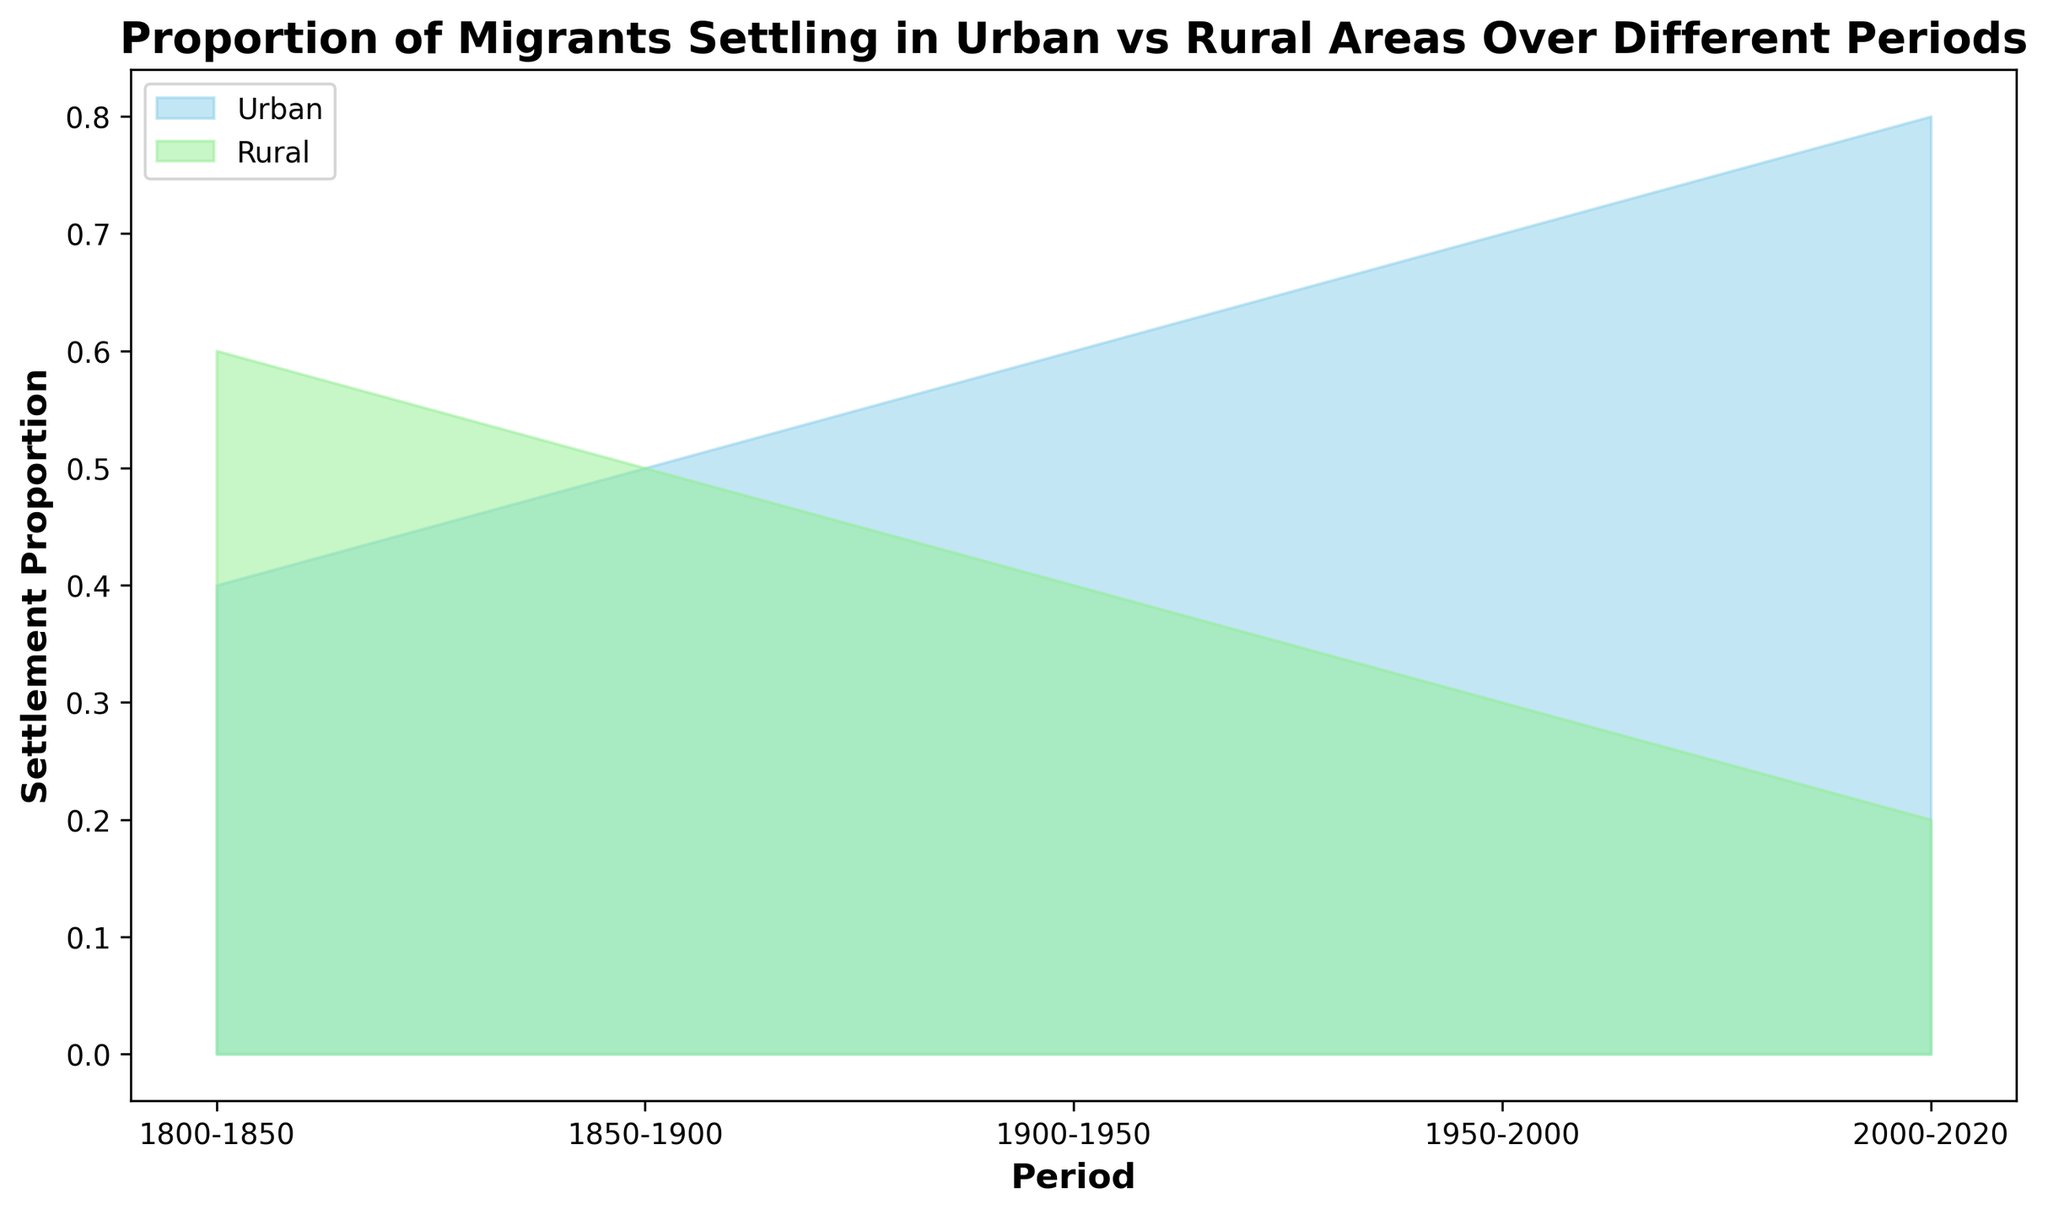What period had the lowest proportion of migrants settling in rural areas? Look at the area chart and identify the period where the green area (representing rural areas) is smallest relative to the total. In the period 2000-2020, the rural proportion is 0.20, the smallest proportion among all periods.
Answer: 2000-2020 How does the proportion of migrants settling in urban areas in 1900-1950 compare to 1800-1850? Check the height of the blue area representing urban areas in the periods 1900-1950 and 1800-1850. The urban proportion for 1900-1950 is 0.60, whereas for 1800-1850, it is 0.40, indicating an increase.
Answer: The proportion increased By how much did the urban settlement proportion increase from 1800-1850 to 2000-2020? Subtract the urban settlement proportion of 1800-1850 (0.40) from the proportion in 2000-2020 (0.80). The calculation is 0.80 - 0.40 = 0.40.
Answer: 0.40 What trend can be observed in the proportion of migrants settling in rural areas over time? Observe the green area in the chart across all periods. The green area decreases over time from 0.60 in 1800-1850 to 0.20 in 2000-2020. This indicates a decreasing trend in rural settlements over time.
Answer: Decreasing trend In which period do urban and rural settlements have equal proportions? Look at the chart to find the period where both the blue and green areas are of equal height. In the period 1850-1900, both urban and rural proportions are 0.50.
Answer: 1850-1900 Which period saw the largest change in the settlement proportion for urban areas compared to the previous period? Calculate the difference in urban settlement proportion between consecutive periods: 
- 1850-1900 to 1900-1950: 0.50 to 0.60 (0.10 change)
- 1900-1950 to 1950-2000: 0.60 to 0.70 (0.10 change)
- 1950-2000 to 2000-2020: 0.70 to 0.80 (0.10 change)
The periods 1850-1900 to 1900-1950, 1900-1950 to 1950-2000, and 1950-2000 to 2000-2020 all have an equal largest change of 0.10.
Answer: 1850-1900 to 1900-1950 / 1900-1950 to 1950-2000 / 1950-2000 to 2000-2020 (all equal) Which area, urban or rural, is visually represented by the sky-blue color? Look at the legend in the area chart which indicates that the sky-blue color represents urban areas.
Answer: Urban During which period did the rural settlement proportion experience a sudden drop, and what was the magnitude of this drop? Identify the period where a noticeable decrease in the green area occurs. From 1950-2000, the rural area proportion drops from 0.40 to 0.30, a magnitude drop of 0.10.
Answer: 1950-2000, 0.10 Which has the higher proportion in the period 2000-2020: urban or rural areas? Compare the blue and green areas in the period 2000-2020. The urban area proportion (blue) is 0.80, which is higher than the rural area proportion (green) of 0.20.
Answer: Urban 